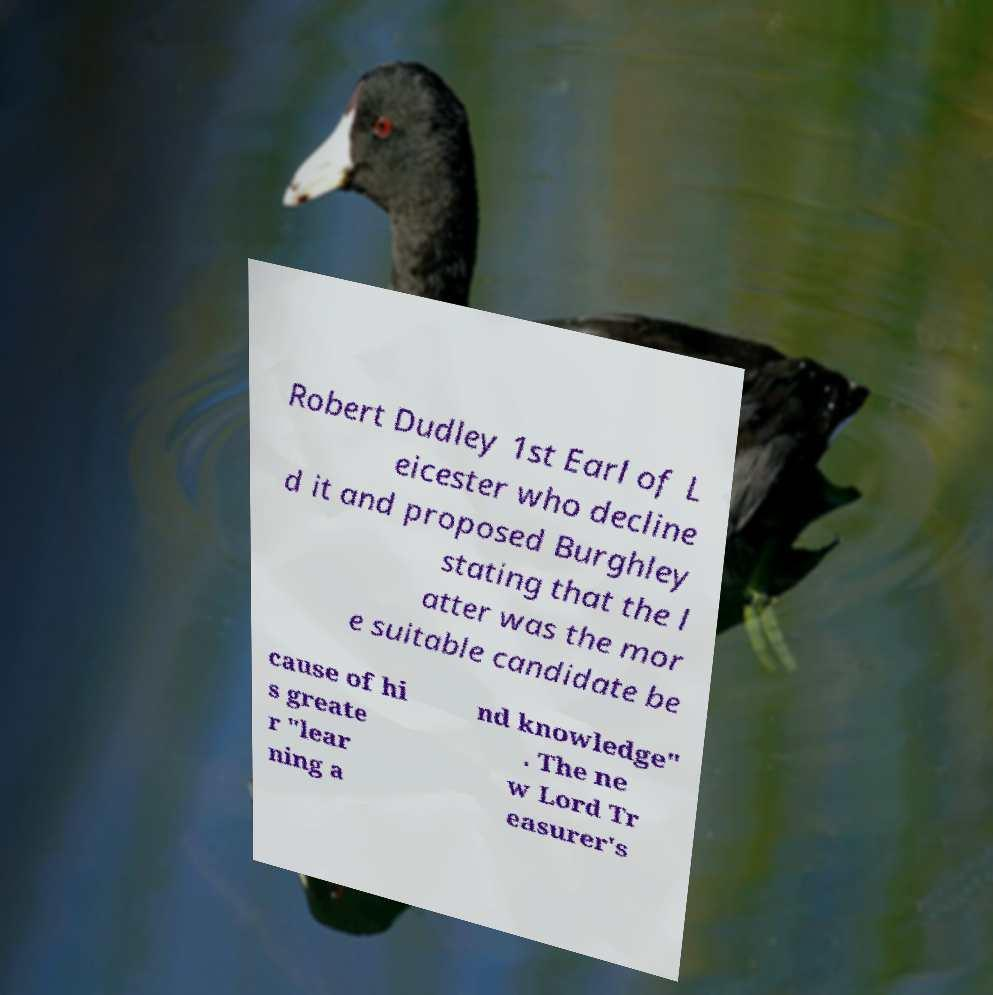Could you assist in decoding the text presented in this image and type it out clearly? Robert Dudley 1st Earl of L eicester who decline d it and proposed Burghley stating that the l atter was the mor e suitable candidate be cause of hi s greate r "lear ning a nd knowledge" . The ne w Lord Tr easurer's 